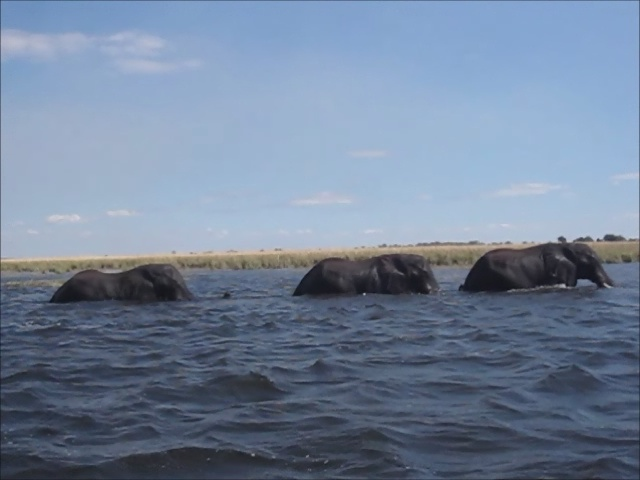Describe the objects in this image and their specific colors. I can see elephant in darkblue, black, and gray tones, elephant in darkblue, black, and gray tones, and elephant in darkblue, black, and gray tones in this image. 